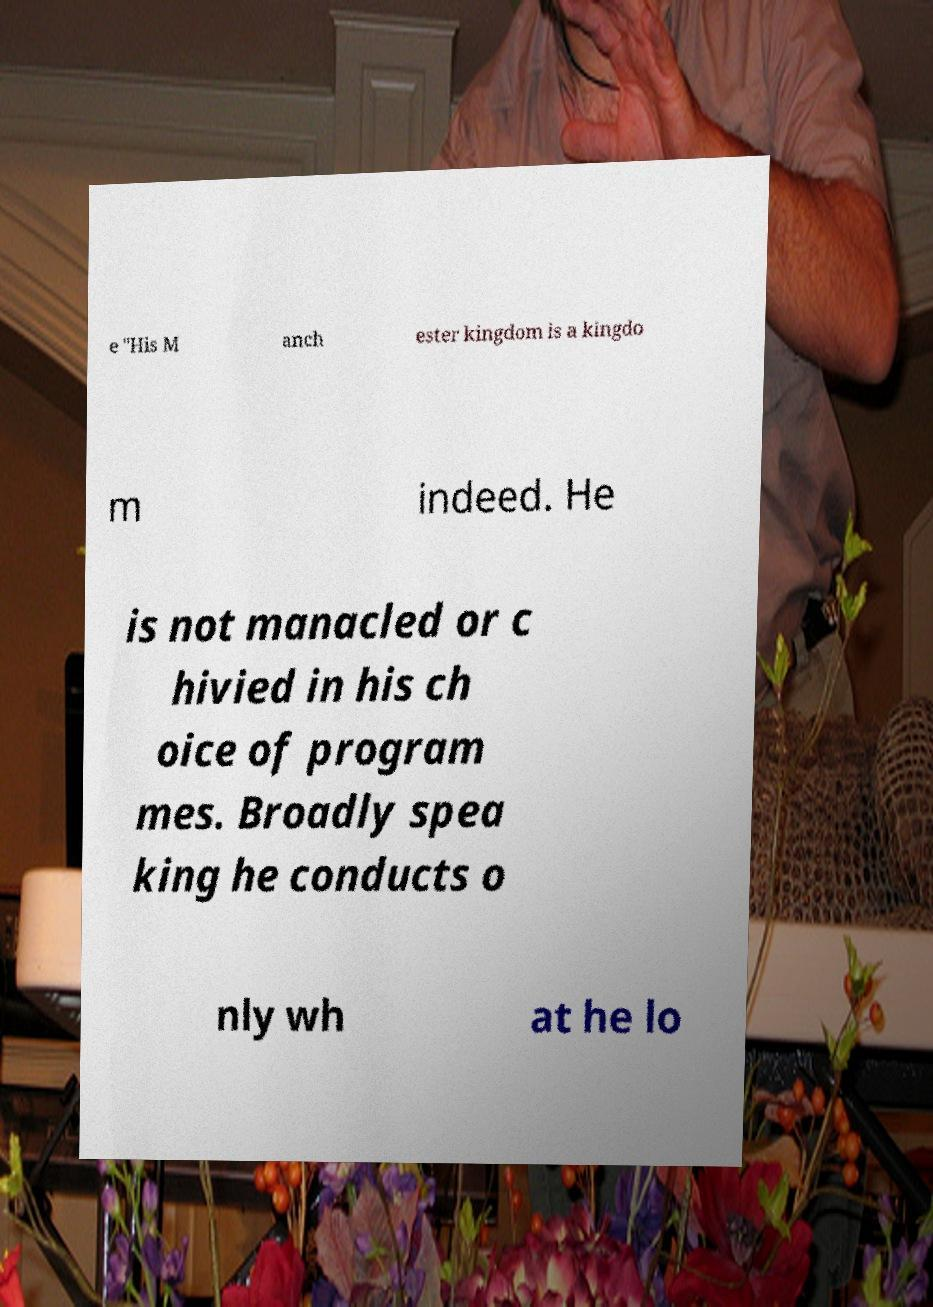Can you accurately transcribe the text from the provided image for me? e "His M anch ester kingdom is a kingdo m indeed. He is not manacled or c hivied in his ch oice of program mes. Broadly spea king he conducts o nly wh at he lo 